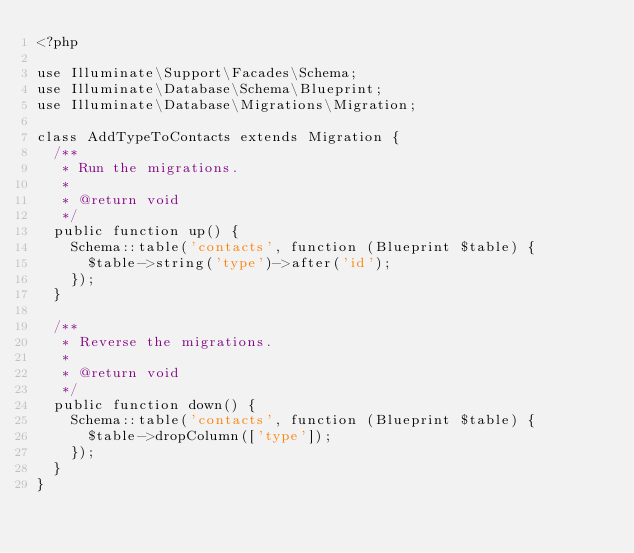Convert code to text. <code><loc_0><loc_0><loc_500><loc_500><_PHP_><?php

use Illuminate\Support\Facades\Schema;
use Illuminate\Database\Schema\Blueprint;
use Illuminate\Database\Migrations\Migration;

class AddTypeToContacts extends Migration {
  /**
   * Run the migrations.
   *
   * @return void
   */
  public function up() {
    Schema::table('contacts', function (Blueprint $table) {
      $table->string('type')->after('id');
    });
  }

  /**
   * Reverse the migrations.
   *
   * @return void
   */
  public function down() {
    Schema::table('contacts', function (Blueprint $table) {
      $table->dropColumn(['type']);
    });
  }
}
</code> 